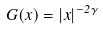Convert formula to latex. <formula><loc_0><loc_0><loc_500><loc_500>G ( x ) = | x | ^ { - 2 \gamma }</formula> 